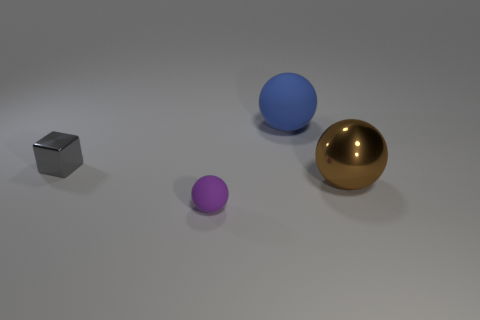Are the object that is to the right of the big blue rubber sphere and the purple ball made of the same material?
Make the answer very short. No. Is there anything else that is the same color as the metallic ball?
Your response must be concise. No. Are the large thing that is on the right side of the big blue thing and the small object that is in front of the block made of the same material?
Provide a succinct answer. No. Are there any other things that have the same shape as the small gray object?
Offer a very short reply. No. What is the color of the small rubber object?
Keep it short and to the point. Purple. How many other big brown objects have the same shape as the big metal object?
Make the answer very short. 0. The other sphere that is the same size as the brown ball is what color?
Your answer should be compact. Blue. Is there a big blue rubber ball?
Your response must be concise. Yes. What is the shape of the matte thing on the left side of the big blue sphere?
Offer a terse response. Sphere. What number of big things are behind the gray shiny block and to the right of the blue thing?
Your response must be concise. 0. 